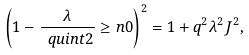Convert formula to latex. <formula><loc_0><loc_0><loc_500><loc_500>\left ( 1 - \frac { \lambda } { \ q u i n t { 2 } } \geq n { 0 } \right ) ^ { 2 } = 1 + q ^ { 2 } \lambda ^ { 2 } J ^ { 2 } ,</formula> 